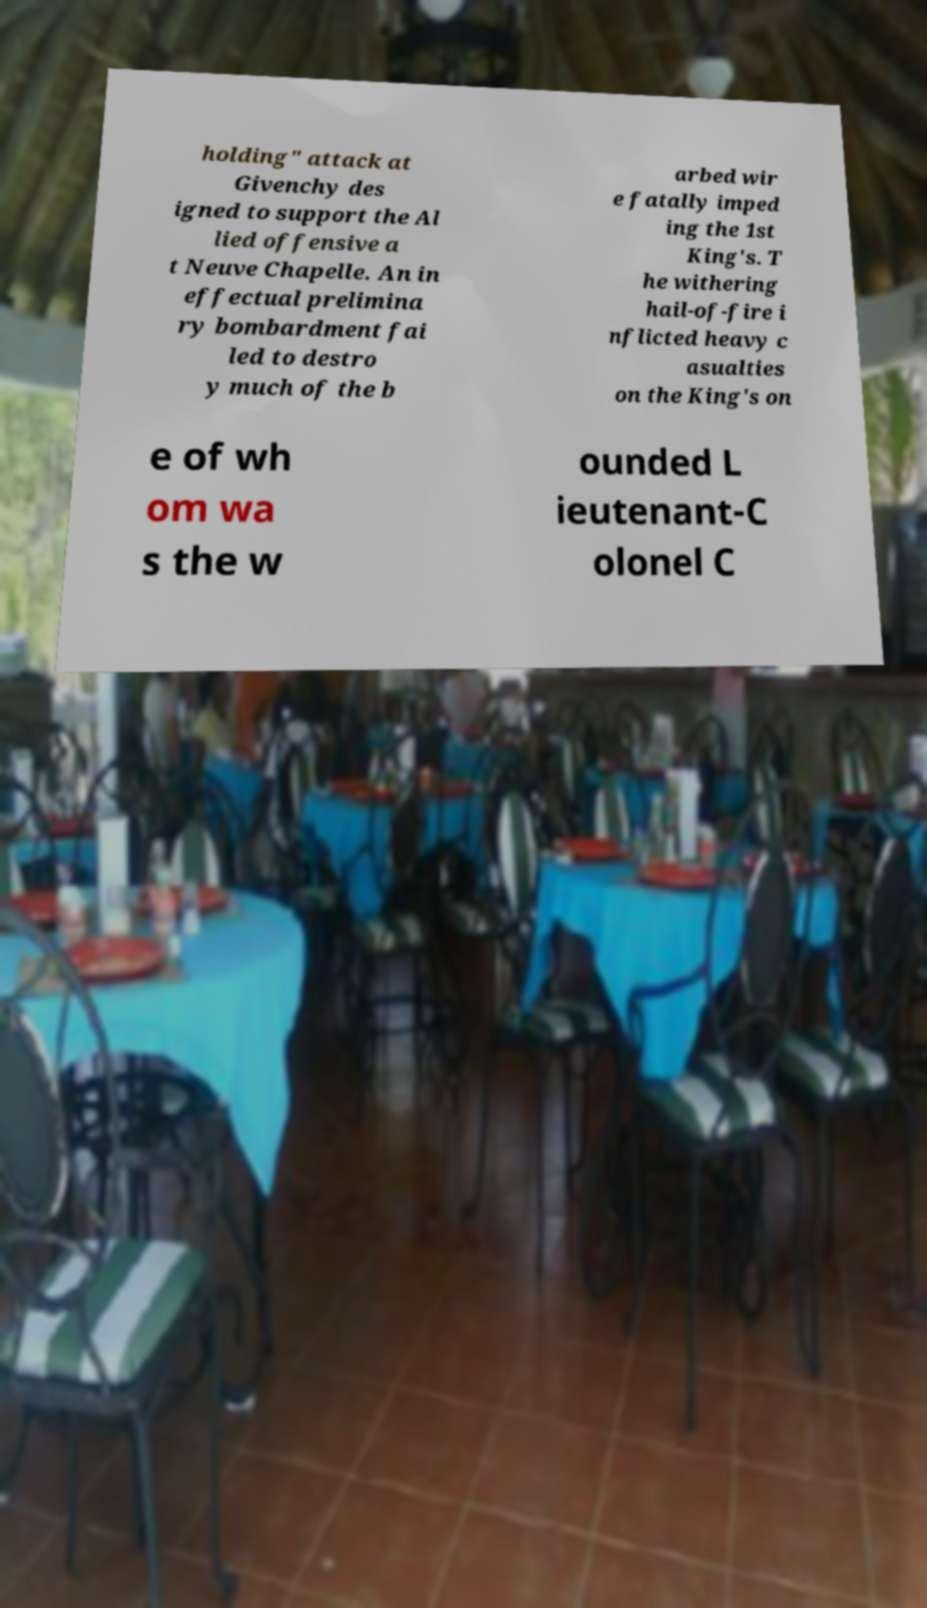Could you assist in decoding the text presented in this image and type it out clearly? holding" attack at Givenchy des igned to support the Al lied offensive a t Neuve Chapelle. An in effectual prelimina ry bombardment fai led to destro y much of the b arbed wir e fatally imped ing the 1st King's. T he withering hail-of-fire i nflicted heavy c asualties on the King's on e of wh om wa s the w ounded L ieutenant-C olonel C 